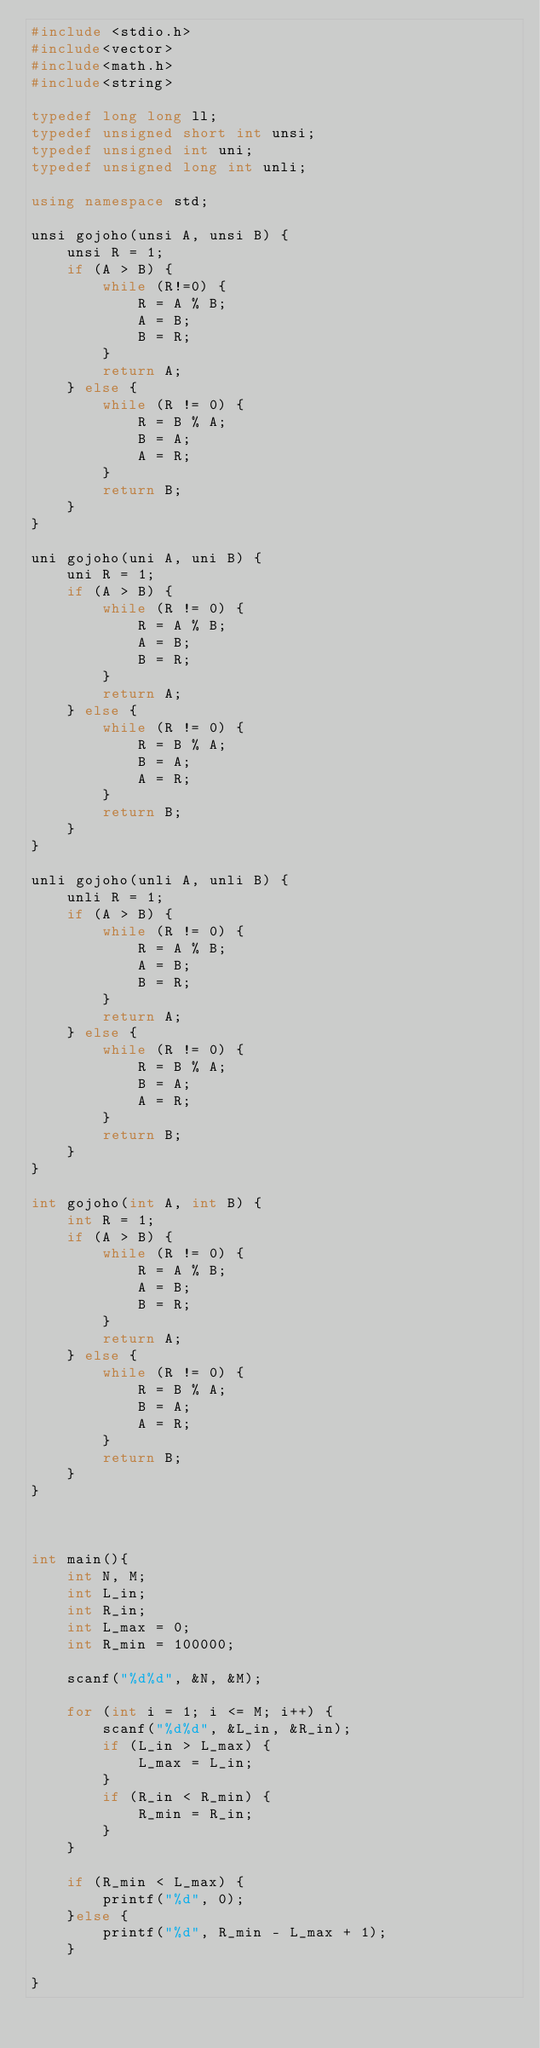Convert code to text. <code><loc_0><loc_0><loc_500><loc_500><_C++_>#include <stdio.h>
#include<vector>
#include<math.h>
#include<string>

typedef long long ll;
typedef unsigned short int unsi;
typedef unsigned int uni;
typedef unsigned long int unli;

using namespace std;

unsi gojoho(unsi A, unsi B) {
	unsi R = 1;
	if (A > B) {
		while (R!=0) {
			R = A % B;
			A = B;
			B = R;
		}
		return A;
	} else {
		while (R != 0) {
			R = B % A;
			B = A;
			A = R;
		}
		return B;
	}
}

uni gojoho(uni A, uni B) {
	uni R = 1;
	if (A > B) {
		while (R != 0) {
			R = A % B;
			A = B;
			B = R;
		}
		return A;
	} else {
		while (R != 0) {
			R = B % A;
			B = A;
			A = R;
		}
		return B;
	}
}

unli gojoho(unli A, unli B) {
	unli R = 1;
	if (A > B) {
		while (R != 0) {
			R = A % B;
			A = B;
			B = R;
		}
		return A;
	} else {
		while (R != 0) {
			R = B % A;
			B = A;
			A = R;
		}
		return B;
	}
}

int gojoho(int A, int B) {
	int R = 1;
	if (A > B) {
		while (R != 0) {
			R = A % B;
			A = B;
			B = R;
		}
		return A;
	} else {
		while (R != 0) {
			R = B % A;
			B = A;
			A = R;
		}
		return B;
	}
}



int main(){
	int N, M;
	int L_in;
	int R_in;
	int L_max = 0;
	int R_min = 100000;

	scanf("%d%d", &N, &M);
	
	for (int i = 1; i <= M; i++) {
		scanf("%d%d", &L_in, &R_in);
		if (L_in > L_max) {
			L_max = L_in;
		}
		if (R_in < R_min) {
			R_min = R_in;
		}
	}

	if (R_min < L_max) {
		printf("%d", 0);
	}else {
		printf("%d", R_min - L_max + 1);
	}
	
}
</code> 